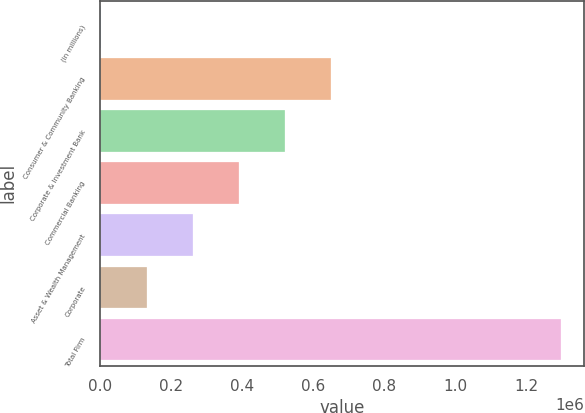Convert chart. <chart><loc_0><loc_0><loc_500><loc_500><bar_chart><fcel>(in millions)<fcel>Consumer & Community Banking<fcel>Corporate & Investment Bank<fcel>Commercial Banking<fcel>Asset & Wealth Management<fcel>Corporate<fcel>Total Firm<nl><fcel>2015<fcel>648902<fcel>519524<fcel>390147<fcel>260770<fcel>131392<fcel>1.29579e+06<nl></chart> 